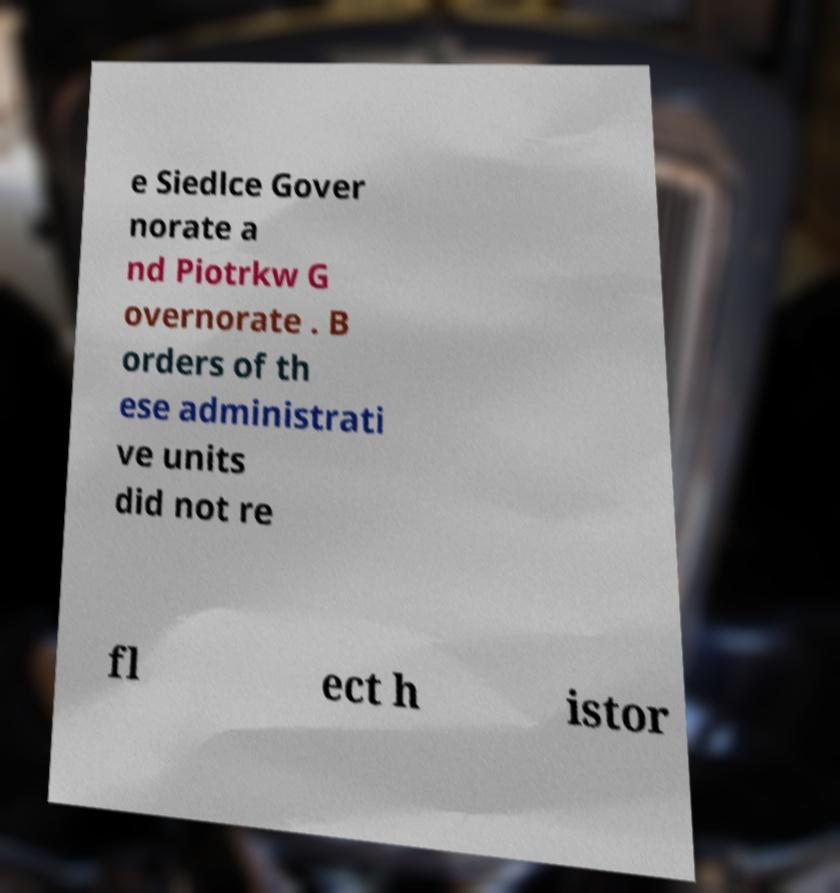What messages or text are displayed in this image? I need them in a readable, typed format. e Siedlce Gover norate a nd Piotrkw G overnorate . B orders of th ese administrati ve units did not re fl ect h istor 